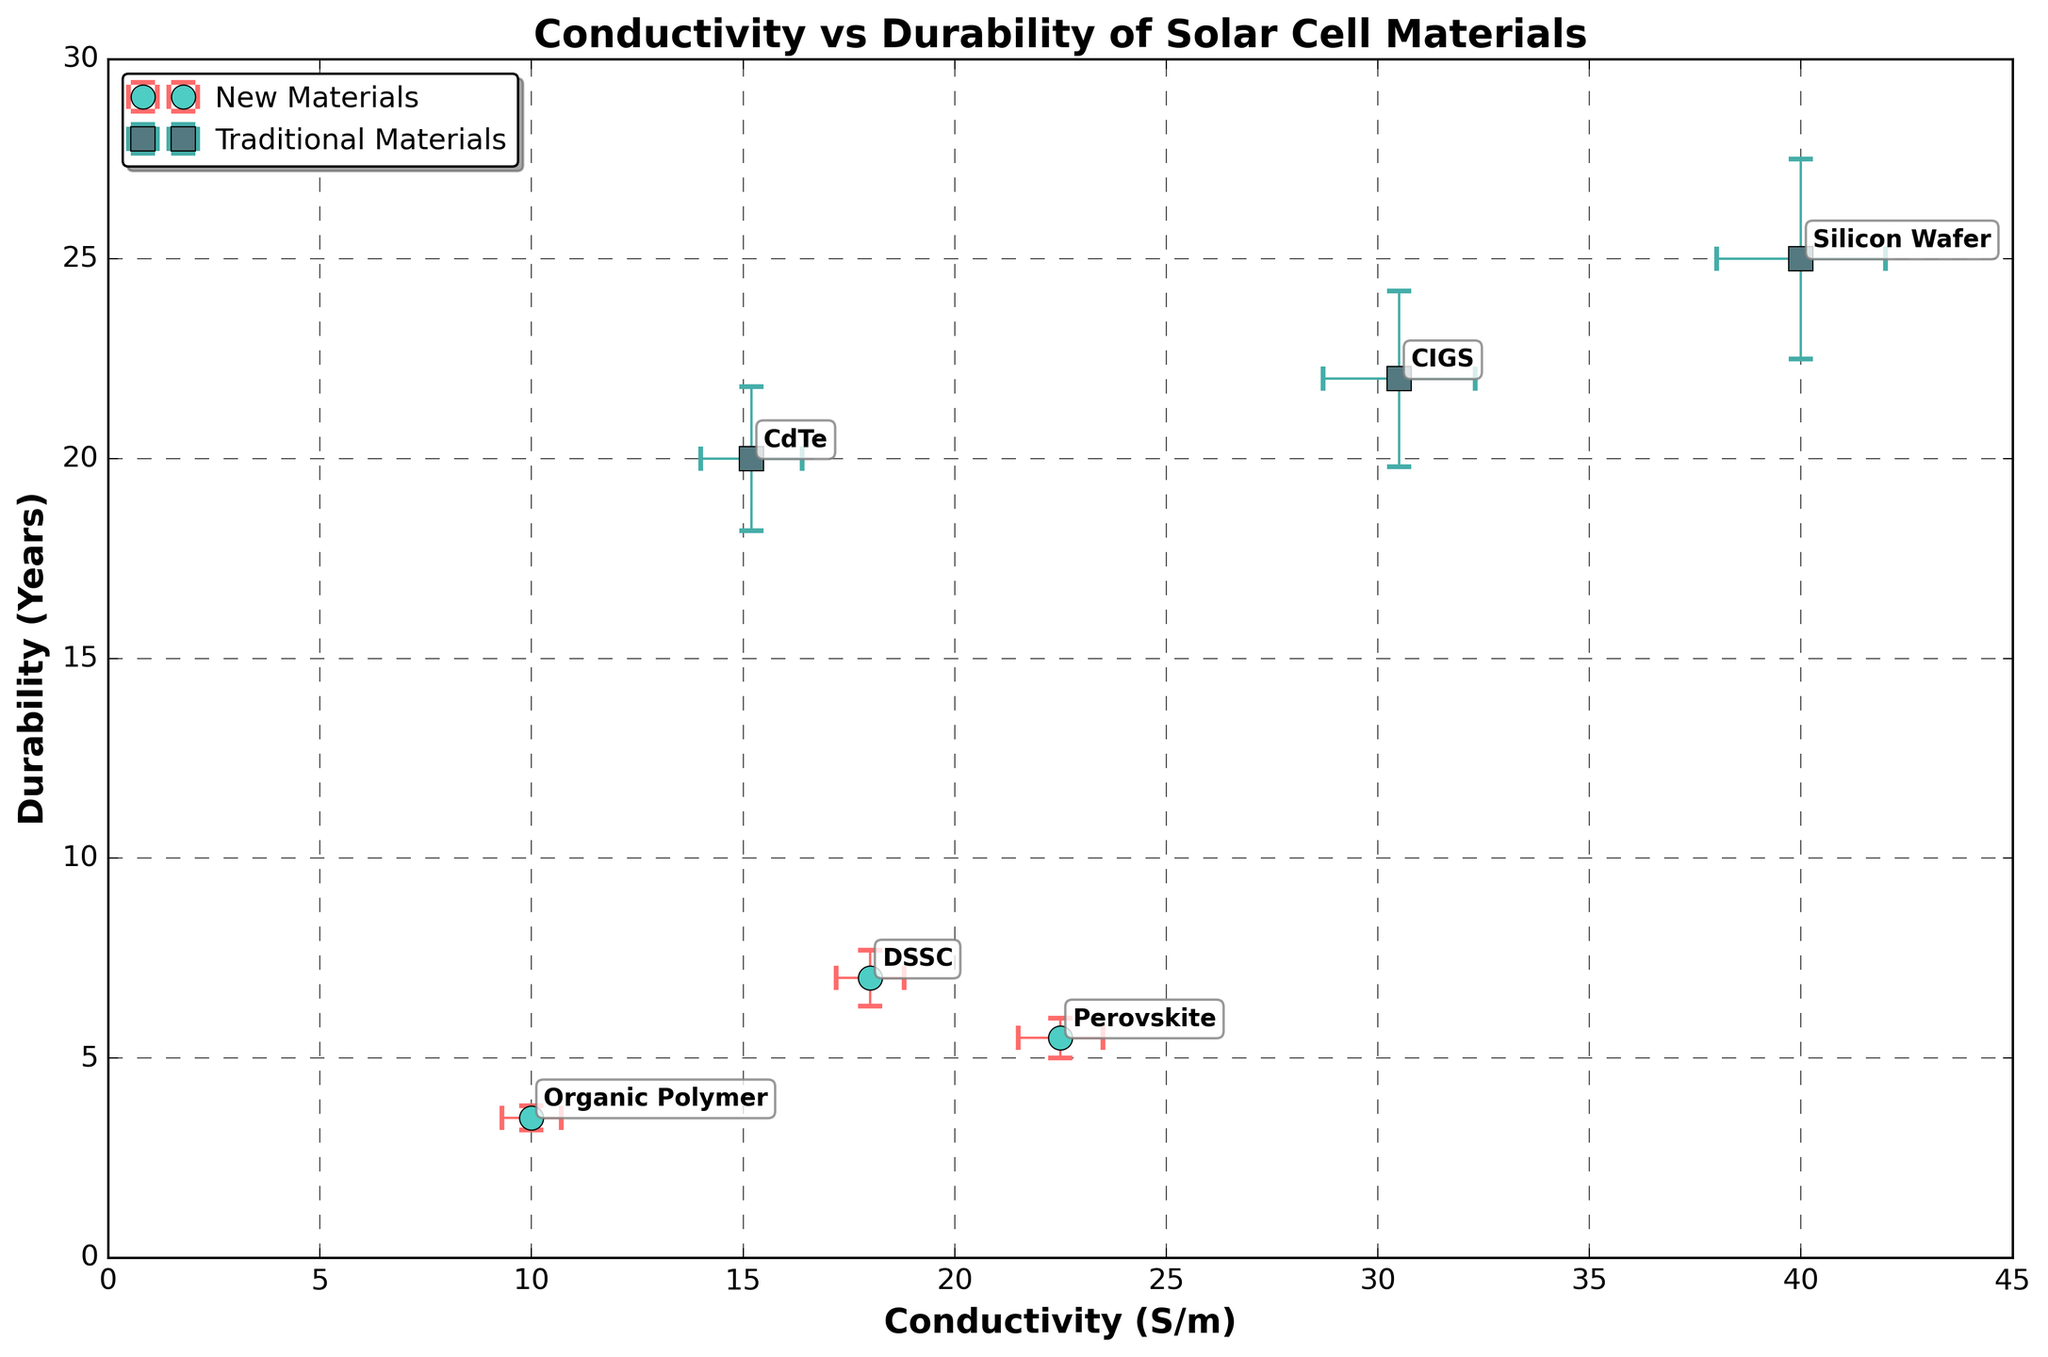what is the main aim/purpose of this research? The title of the figure is 'Conductivity vs Durability of Solar Cell Materials', which suggests that the main aim is to compare the conductivity and durability of new versus traditional solar cell materials.
Answer: To compare the conductivity and durability of different solar cell materials Which material has the highest conductivity? By observing the x-axis which represents conductivity, 'Silicon Wafer' has the highest value among all the dots.
Answer: Silicon Wafer Which material has the lowest durability? By observing the y-axis which represents durability, 'Organic Polymer' has the lowest value among all the dots.
Answer: Organic Polymer How do Perovskite and DSSC compare in terms of conductivity? By comparing the x-values of 'Perovskite' and 'DSSC', it's visible that Perovskite has a higher conductivity than DSSC.
Answer: Perovskite has higher conductivity Which traditional material has the lowest conductivity? The traditional materials on the plot are 'CdTe', 'Silicon Wafer', and 'CIGS'. Among these, 'CdTe' has the lowest x-value.
Answer: CdTe What is the durability difference between CdTe and Silicon Wafer? Observe the y-values where CdTe has a value of 20 years and Silicon Wafer has 25 years. The difference is 25 - 20 = 5 years.
Answer: 5 years Which new material has the highest durability? By examining the y-values of new materials ('Perovskite', 'DSSC', and 'Organic Polymer'), DSSC has the highest value.
Answer: DSSC Between which two materials is the conductivity error the largest? By examining the x-error bars, the material pair with the largest difference in x-error bar size is 'Silicon Wafer' and 'CdTe'.
Answer: Silicon Wafer and CdTe Which material is least durable but still conducts relatively well? 'Organic Polymer' has the lowest durability by observing the y-values, however among new materials it has relatively higher conductivity, visible from the x-values.
Answer: Organic Polymer 